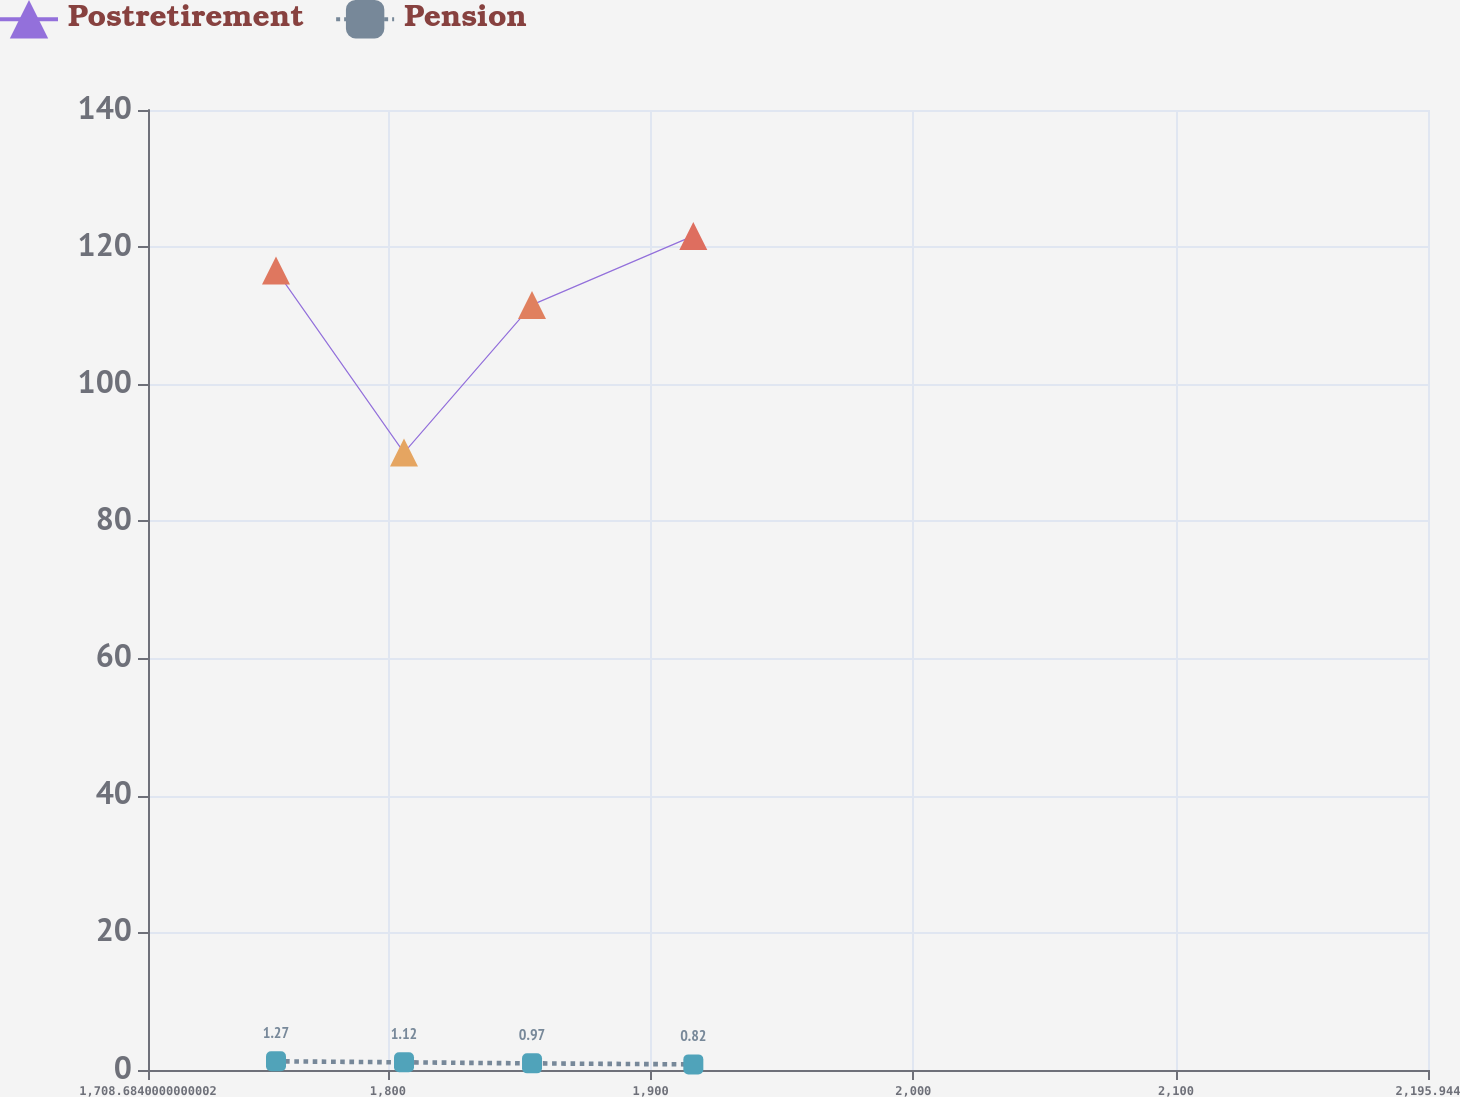Convert chart to OTSL. <chart><loc_0><loc_0><loc_500><loc_500><line_chart><ecel><fcel>Postretirement<fcel>Pension<nl><fcel>1757.41<fcel>116.61<fcel>1.27<nl><fcel>1806.14<fcel>90.04<fcel>1.12<nl><fcel>1854.87<fcel>111.58<fcel>0.97<nl><fcel>1916.28<fcel>121.64<fcel>0.82<nl><fcel>2244.67<fcel>140.34<fcel>2.35<nl></chart> 